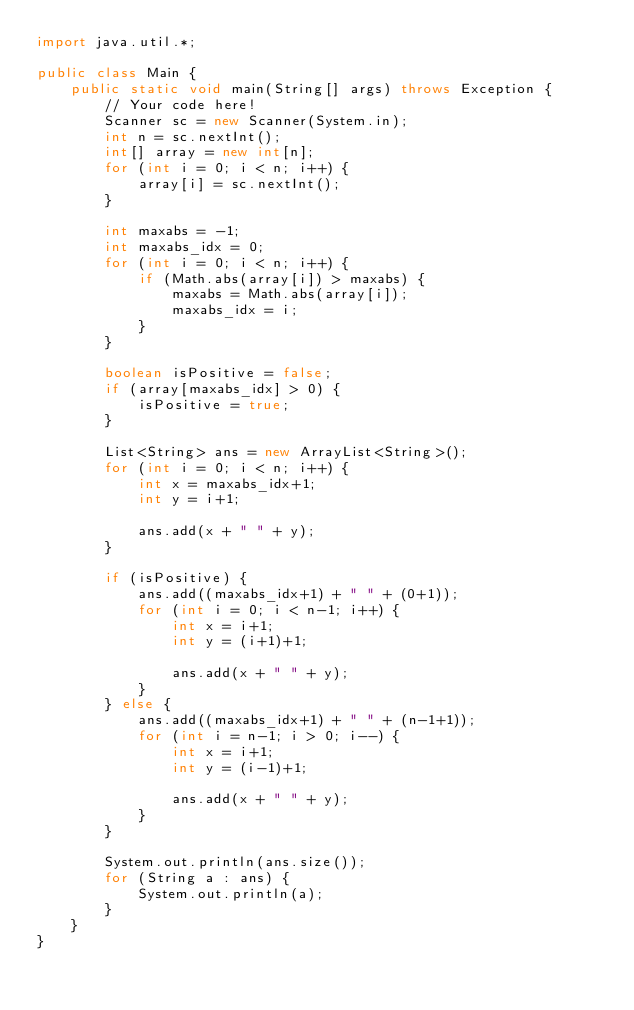Convert code to text. <code><loc_0><loc_0><loc_500><loc_500><_Java_>import java.util.*;

public class Main {
    public static void main(String[] args) throws Exception {
        // Your code here!
        Scanner sc = new Scanner(System.in);
        int n = sc.nextInt();
        int[] array = new int[n];
        for (int i = 0; i < n; i++) {
            array[i] = sc.nextInt();
        }
        
        int maxabs = -1;
        int maxabs_idx = 0;
        for (int i = 0; i < n; i++) {
            if (Math.abs(array[i]) > maxabs) {
                maxabs = Math.abs(array[i]);
                maxabs_idx = i;
            }
        }
        
        boolean isPositive = false;
        if (array[maxabs_idx] > 0) {
            isPositive = true;
        }
        
        List<String> ans = new ArrayList<String>();
        for (int i = 0; i < n; i++) {
            int x = maxabs_idx+1;
            int y = i+1;
            
            ans.add(x + " " + y);
        }
        
        if (isPositive) {
            ans.add((maxabs_idx+1) + " " + (0+1));
            for (int i = 0; i < n-1; i++) {
                int x = i+1;
                int y = (i+1)+1;
                
                ans.add(x + " " + y);
            }
        } else {
            ans.add((maxabs_idx+1) + " " + (n-1+1));
            for (int i = n-1; i > 0; i--) {
                int x = i+1;
                int y = (i-1)+1;
                
                ans.add(x + " " + y);
            }
        }
        
        System.out.println(ans.size());
        for (String a : ans) {
            System.out.println(a);
        }
    }
}
</code> 